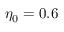Convert formula to latex. <formula><loc_0><loc_0><loc_500><loc_500>\eta _ { 0 } = 0 . 6</formula> 